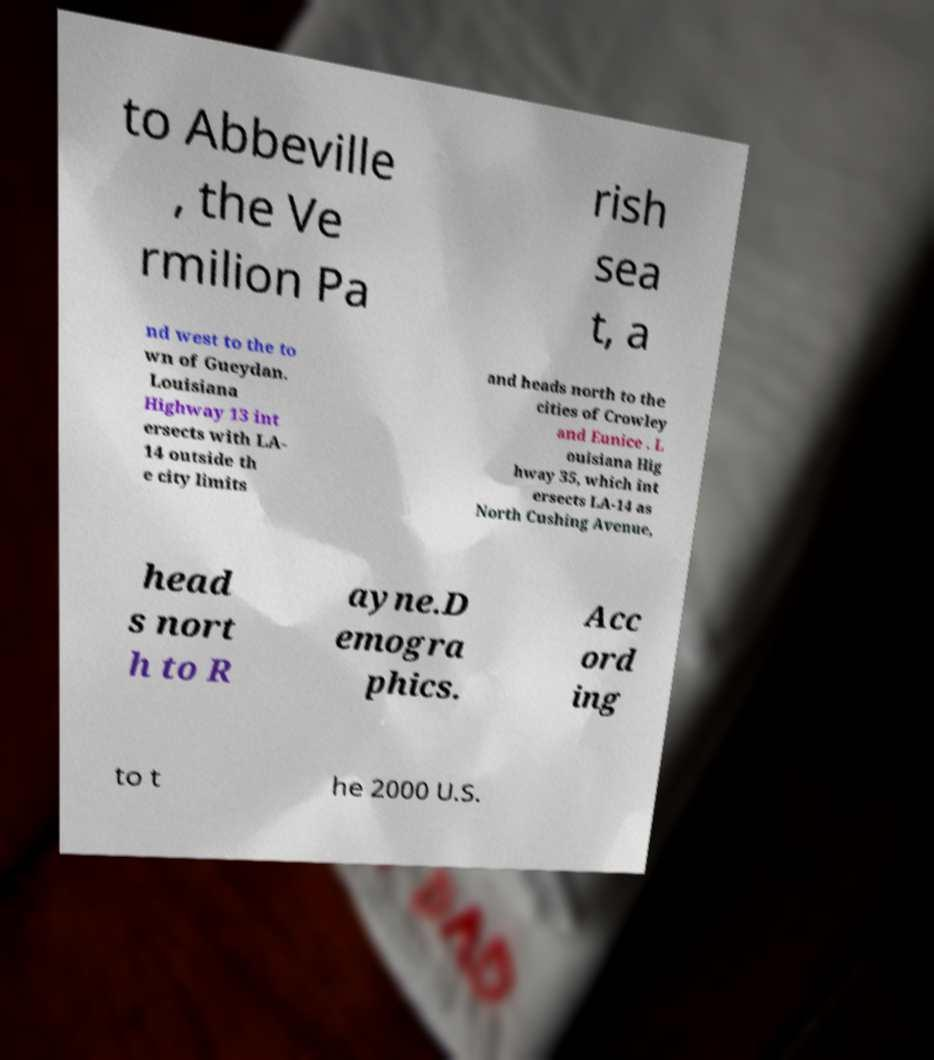Please identify and transcribe the text found in this image. to Abbeville , the Ve rmilion Pa rish sea t, a nd west to the to wn of Gueydan. Louisiana Highway 13 int ersects with LA- 14 outside th e city limits and heads north to the cities of Crowley and Eunice . L ouisiana Hig hway 35, which int ersects LA-14 as North Cushing Avenue, head s nort h to R ayne.D emogra phics. Acc ord ing to t he 2000 U.S. 